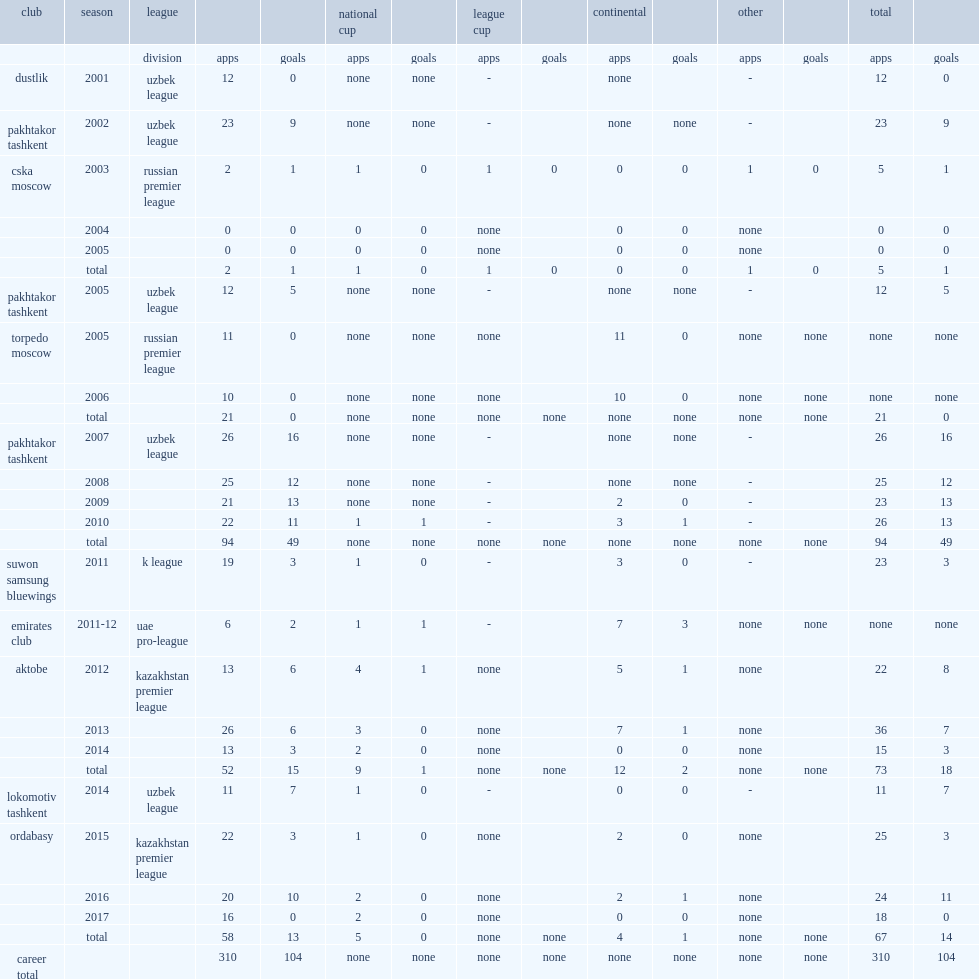Which club did geynrikh play for in 2015? Ordabasy. 